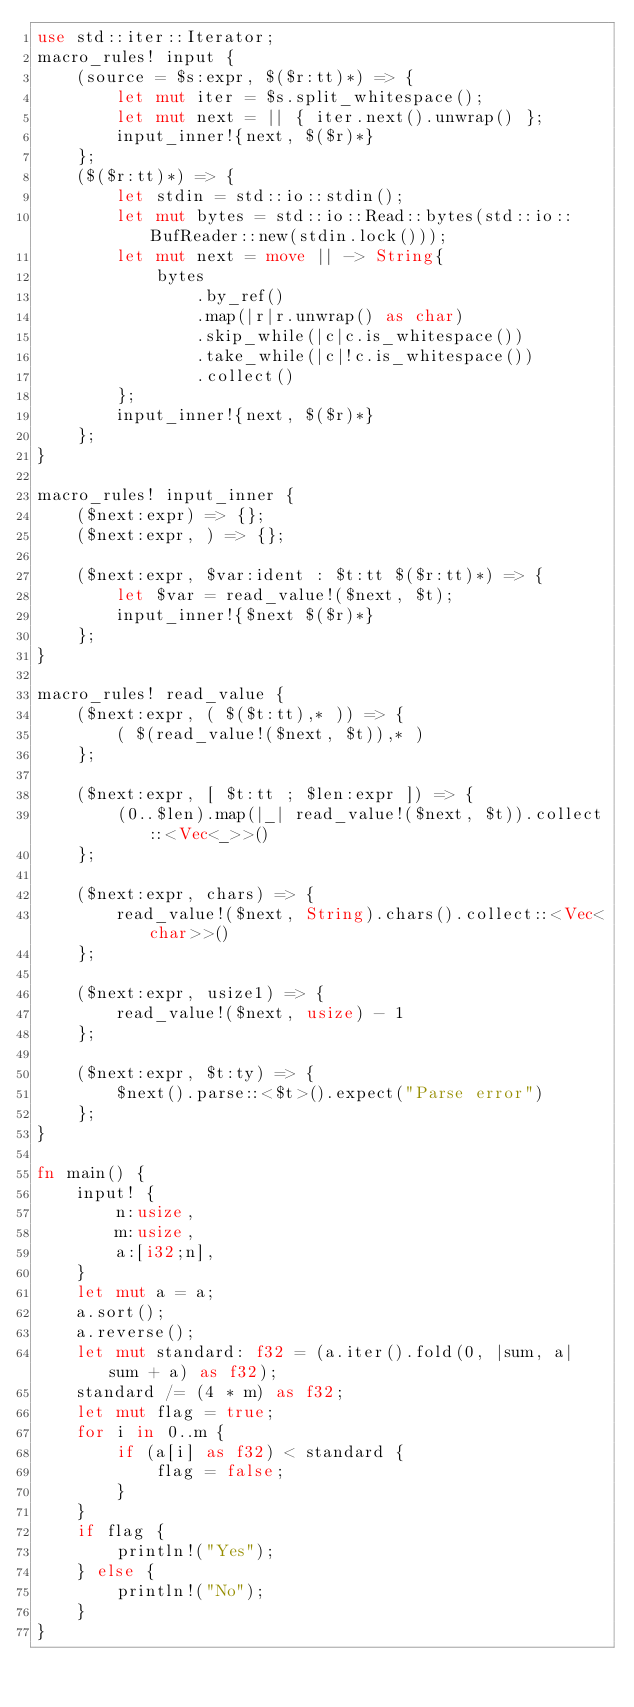Convert code to text. <code><loc_0><loc_0><loc_500><loc_500><_Rust_>use std::iter::Iterator;
macro_rules! input {
    (source = $s:expr, $($r:tt)*) => {
        let mut iter = $s.split_whitespace();
        let mut next = || { iter.next().unwrap() };
        input_inner!{next, $($r)*}
    };
    ($($r:tt)*) => {
        let stdin = std::io::stdin();
        let mut bytes = std::io::Read::bytes(std::io::BufReader::new(stdin.lock()));
        let mut next = move || -> String{
            bytes
                .by_ref()
                .map(|r|r.unwrap() as char)
                .skip_while(|c|c.is_whitespace())
                .take_while(|c|!c.is_whitespace())
                .collect()
        };
        input_inner!{next, $($r)*}
    };
}

macro_rules! input_inner {
    ($next:expr) => {};
    ($next:expr, ) => {};

    ($next:expr, $var:ident : $t:tt $($r:tt)*) => {
        let $var = read_value!($next, $t);
        input_inner!{$next $($r)*}
    };
}

macro_rules! read_value {
    ($next:expr, ( $($t:tt),* )) => {
        ( $(read_value!($next, $t)),* )
    };

    ($next:expr, [ $t:tt ; $len:expr ]) => {
        (0..$len).map(|_| read_value!($next, $t)).collect::<Vec<_>>()
    };

    ($next:expr, chars) => {
        read_value!($next, String).chars().collect::<Vec<char>>()
    };

    ($next:expr, usize1) => {
        read_value!($next, usize) - 1
    };

    ($next:expr, $t:ty) => {
        $next().parse::<$t>().expect("Parse error")
    };
}

fn main() {
    input! {
        n:usize,
        m:usize,
        a:[i32;n],
    }
    let mut a = a;
    a.sort();
    a.reverse();
    let mut standard: f32 = (a.iter().fold(0, |sum, a| sum + a) as f32);
    standard /= (4 * m) as f32;
    let mut flag = true;
    for i in 0..m {
        if (a[i] as f32) < standard {
            flag = false;
        }
    }
    if flag {
        println!("Yes");
    } else {
        println!("No");
    }
}
</code> 